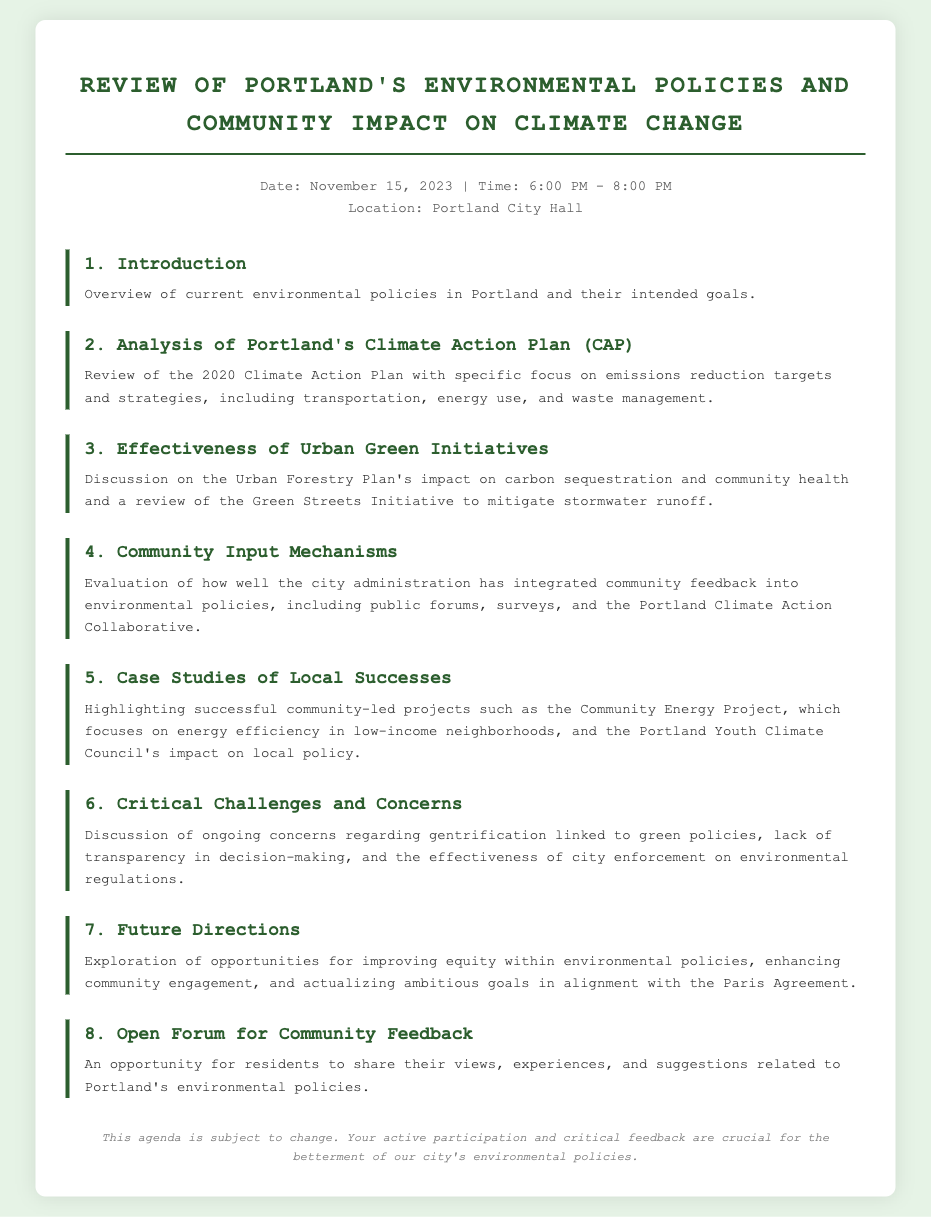What is the date of the agenda? The date of the agenda is listed in the meta section of the document.
Answer: November 15, 2023 What time does the review session begin? The starting time is provided in the meta section of the document.
Answer: 6:00 PM What is the first agenda item? The first agenda item is listed in the document's agenda section.
Answer: Introduction Which plan is reviewed in the second agenda item? The second agenda item specifically mentions a city plan in its description.
Answer: Climate Action Plan What does the sixth agenda item discuss? The sixth agenda item outlines specific topics of concern in the document.
Answer: Critical Challenges and Concerns How many specific case studies are mentioned in the fifth agenda item? The fifth agenda item references successful community-led projects, indicating a number of relevant examples.
Answer: Two What is the purpose of the seventh agenda item? The seventh agenda item focuses on strategic future planning as described in its section.
Answer: Future Directions What is the location of the event? The location is provided in the meta section of the document.
Answer: Portland City Hall What type of feedback will be collected in the eighth agenda item? The eighth agenda item specifies the nature of resident participation sought during the meeting.
Answer: Community Feedback 